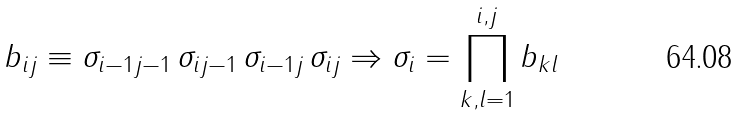Convert formula to latex. <formula><loc_0><loc_0><loc_500><loc_500>b _ { i j } \equiv \sigma _ { i - 1 j - 1 } \, \sigma _ { i j - 1 } \, \sigma _ { i - 1 j } \, \sigma _ { i j } \Rightarrow \sigma _ { i } = \prod _ { k , l = 1 } ^ { i , j } b _ { k l }</formula> 